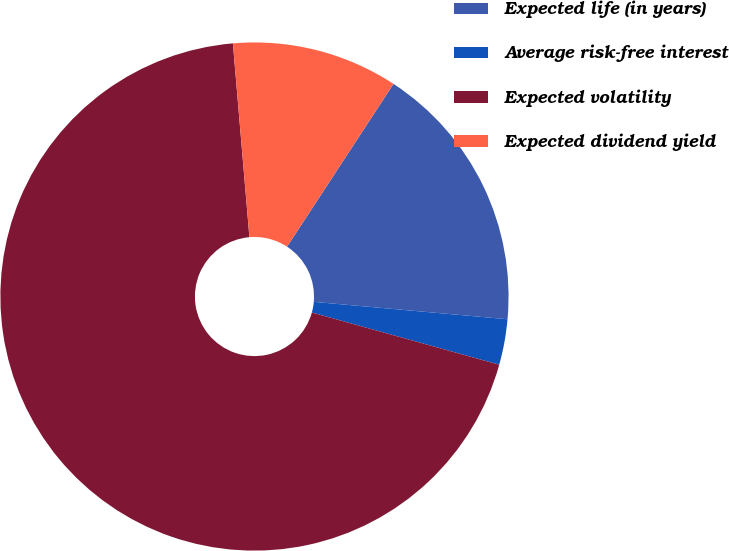Convert chart. <chart><loc_0><loc_0><loc_500><loc_500><pie_chart><fcel>Expected life (in years)<fcel>Average risk-free interest<fcel>Expected volatility<fcel>Expected dividend yield<nl><fcel>17.21%<fcel>2.9%<fcel>69.33%<fcel>10.57%<nl></chart> 